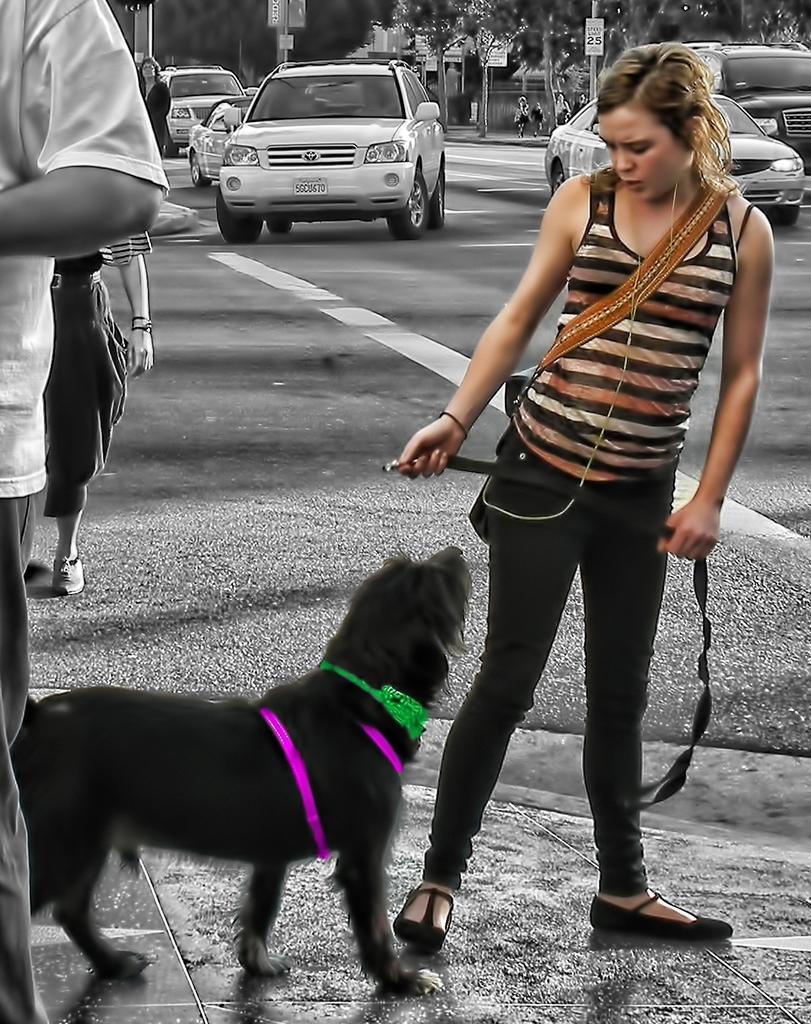Please provide a concise description of this image. In this picture we can see woman and in front of this woman we can see dog looking at her and in the background we can see car on road,trees, pole, sign board and some more persons. 